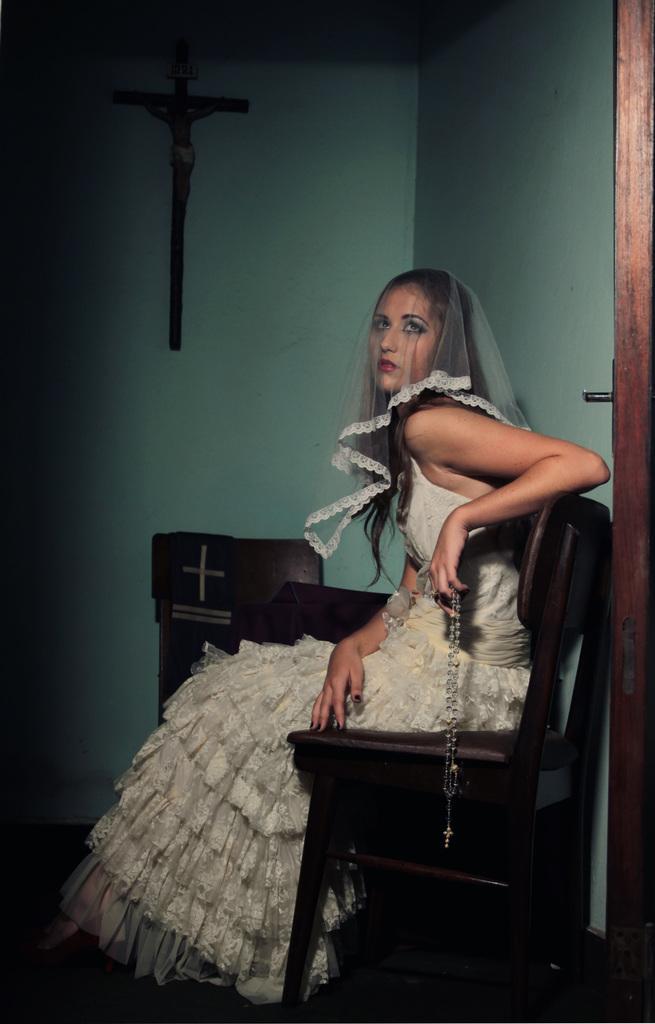Please provide a concise description of this image. In this image, we can see a lady holding an object is sitting. We can see some chairs and the ground. We can see the wall with some objects. We can also see some wood on the right. 